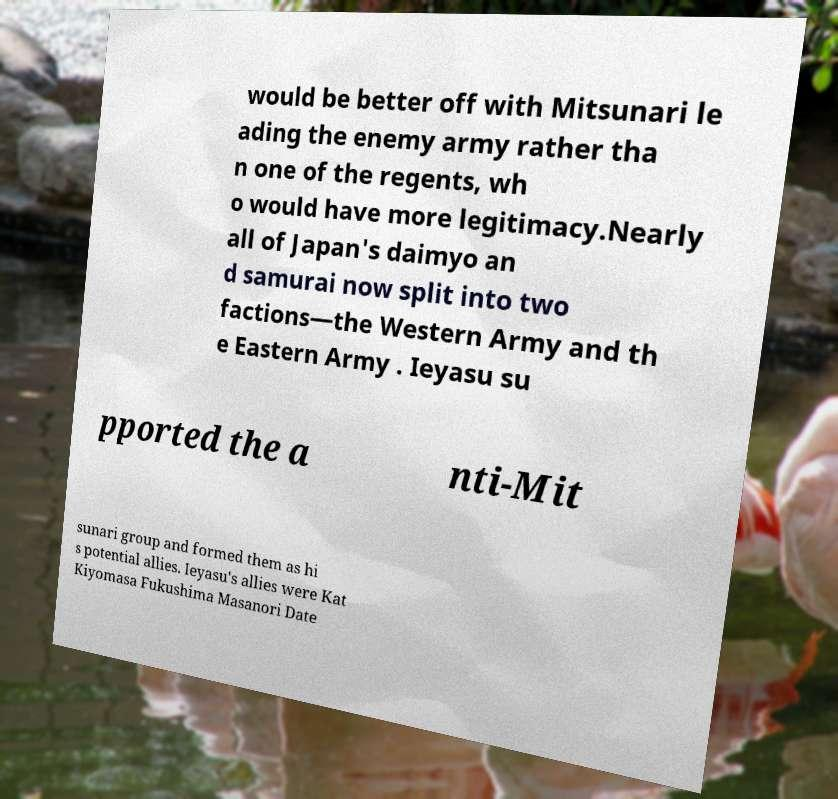Can you read and provide the text displayed in the image?This photo seems to have some interesting text. Can you extract and type it out for me? would be better off with Mitsunari le ading the enemy army rather tha n one of the regents, wh o would have more legitimacy.Nearly all of Japan's daimyo an d samurai now split into two factions—the Western Army and th e Eastern Army . Ieyasu su pported the a nti-Mit sunari group and formed them as hi s potential allies. Ieyasu's allies were Kat Kiyomasa Fukushima Masanori Date 